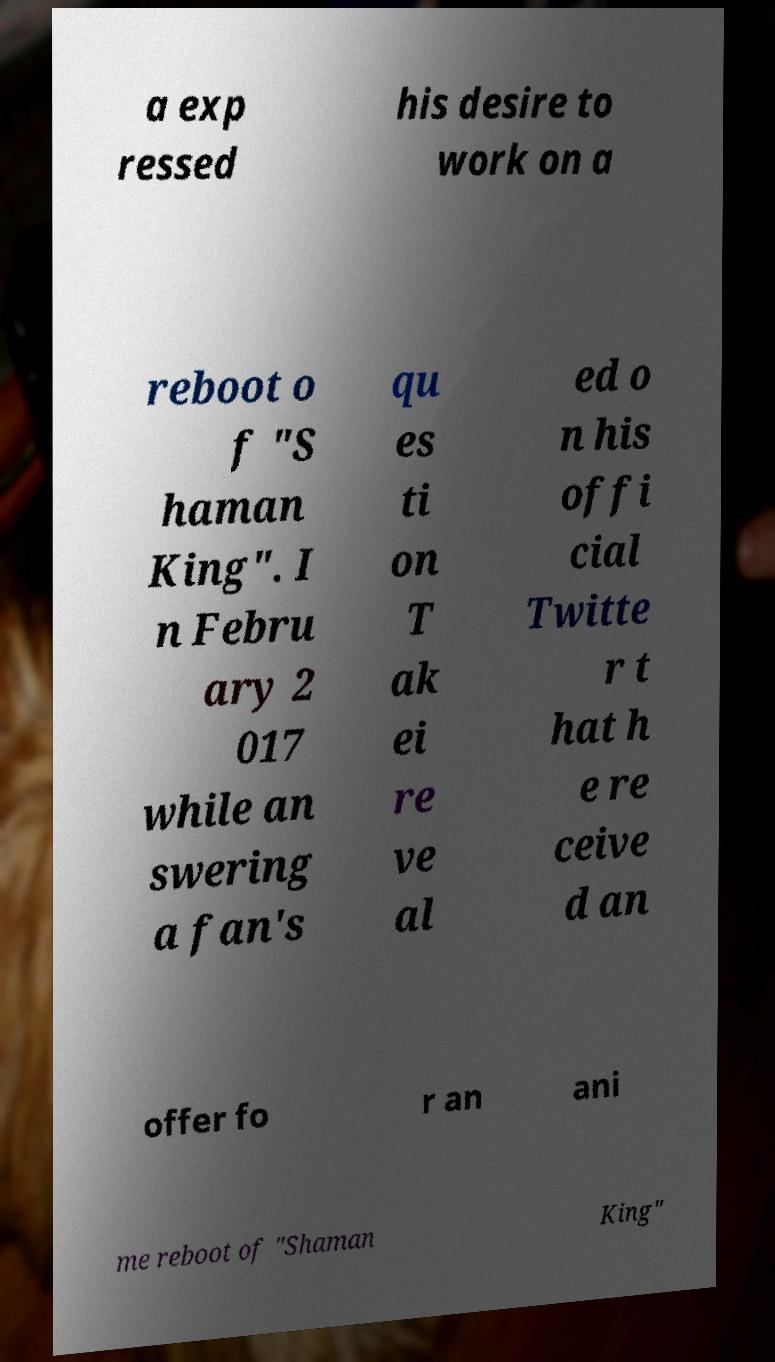For documentation purposes, I need the text within this image transcribed. Could you provide that? a exp ressed his desire to work on a reboot o f "S haman King". I n Febru ary 2 017 while an swering a fan's qu es ti on T ak ei re ve al ed o n his offi cial Twitte r t hat h e re ceive d an offer fo r an ani me reboot of "Shaman King" 